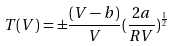<formula> <loc_0><loc_0><loc_500><loc_500>T ( V ) = \pm { \frac { ( V - b ) } { V } } ( \frac { 2 a } { R V } ) ^ { \frac { 1 } { 2 } }</formula> 